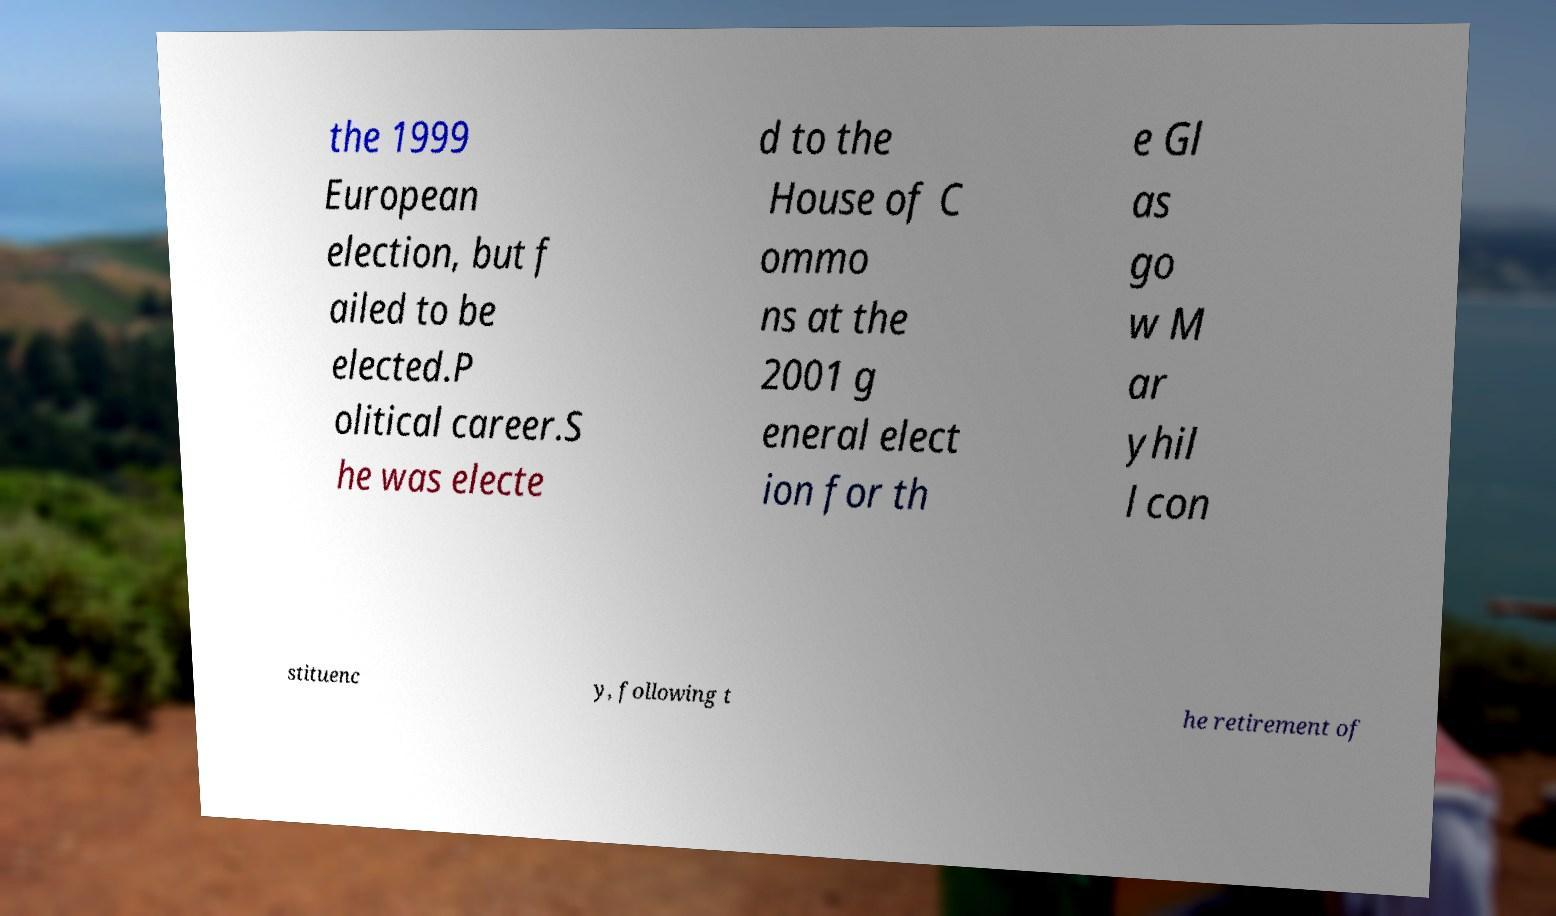I need the written content from this picture converted into text. Can you do that? the 1999 European election, but f ailed to be elected.P olitical career.S he was electe d to the House of C ommo ns at the 2001 g eneral elect ion for th e Gl as go w M ar yhil l con stituenc y, following t he retirement of 